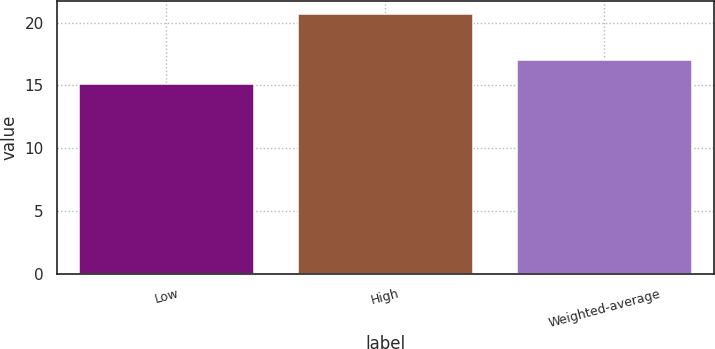Convert chart. <chart><loc_0><loc_0><loc_500><loc_500><bar_chart><fcel>Low<fcel>High<fcel>Weighted-average<nl><fcel>15.1<fcel>20.7<fcel>17<nl></chart> 